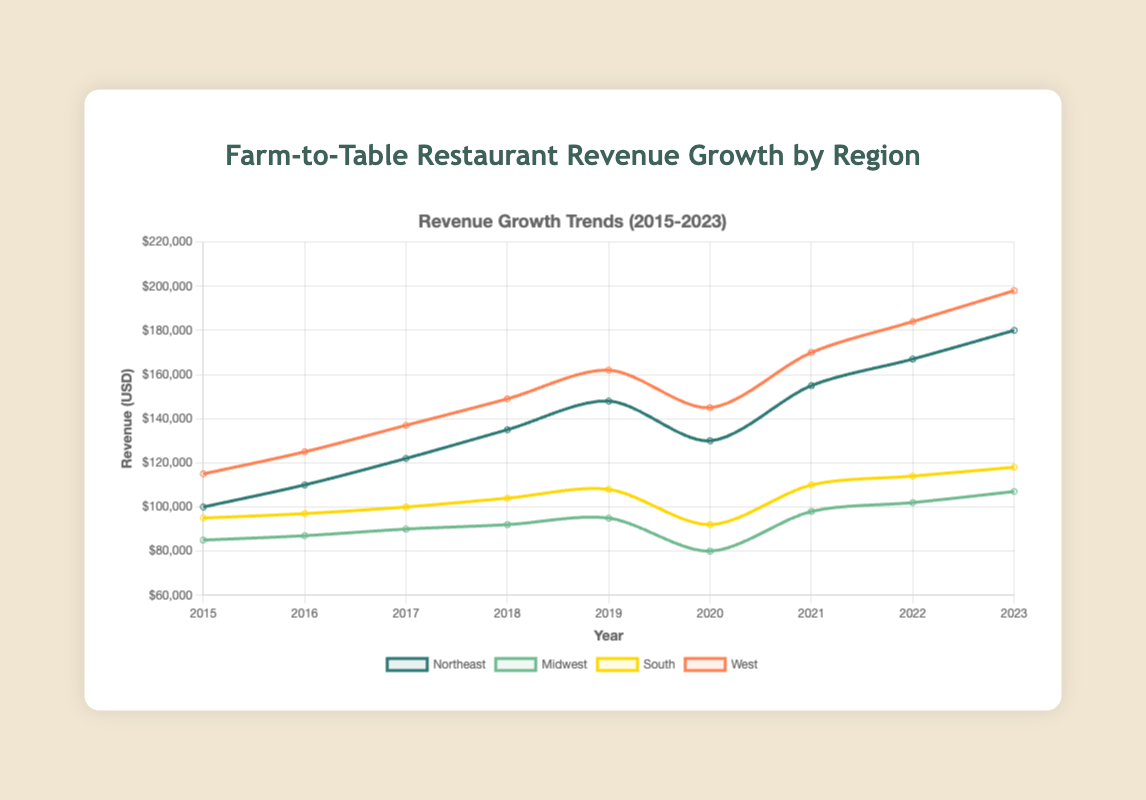Which region had the highest revenue growth in 2023? Looking at the last data point for each region in 2023, the West had the highest revenue, with $198,000.
Answer: West How did the revenue in the Northeast change from 2019 to 2020? The revenue in the Northeast dropped from $148,000 in 2019 to $130,000 in 2020, resulting in a decrease of $18,000.
Answer: Decreased by $18,000 In which year did the Midwest have the lowest revenue? Looking at the line representing the Midwest, the lowest point is in 2020 with a revenue of $80,000.
Answer: 2020 What was the total revenue for the South region from 2015 to 2023? Adding up the revenue for each year in the South region: 95,000 + 97,000 + 100,000 + 104,000 + 108,000 + 92,000 + 110,000 + 114,000 + 118,000 = 938,000.
Answer: $938,000 Which region experienced the sharpest decline between any two consecutive years? Observing the plot, the Northeast had a significant drop between 2019 and 2020, from $148,000 to $130,000, a decrease of $18,000.
Answer: Northeast from 2019 to 2020 Which region had the most stable revenue growth over the years? Observing each line for fluctuation, the South appears to have the most consistent and steady growth without large drops or spikes.
Answer: South What was the average revenue for the West region over the given period? Adding up the revenue for each year in the West region and dividing by the number of years: (115,000 + 125,000 + 137,000 + 149,000 + 162,000 + 145,000 + 170,000 + 184,000 + 198,000) = 1,285,000 / 9 = 142,777.78.
Answer: $142,777.78 In which year did the Northeast and Midwest have the same revenue trend (both increasing or both decreasing)? Both the Northeast and Midwest show a decline in revenue from 2019 to 2020.
Answer: 2020 